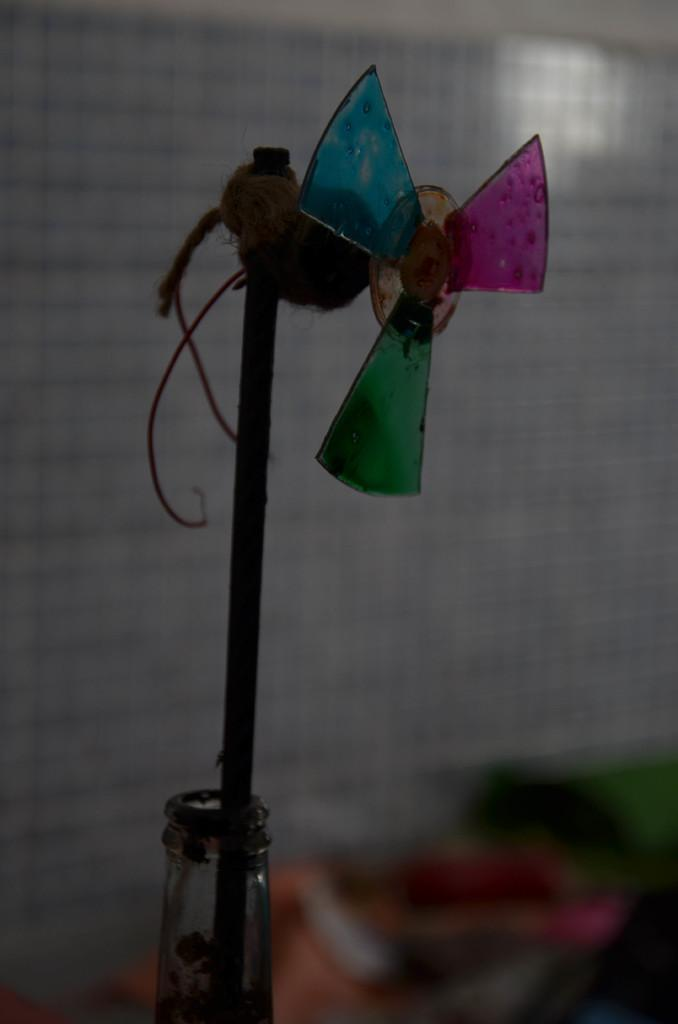What object is inside the bottle in the image? There is a wind fan toy stick in the bottle. Can you describe the background of the image? The background of the image is blurred. What type of oatmeal is being served in the image? There is no oatmeal present in the image; it features a wind fan toy stick in a bottle with a blurred background. 